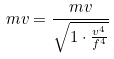Convert formula to latex. <formula><loc_0><loc_0><loc_500><loc_500>m v = \frac { m v } { \sqrt { 1 \cdot \frac { v ^ { 4 } } { f ^ { 4 } } } }</formula> 